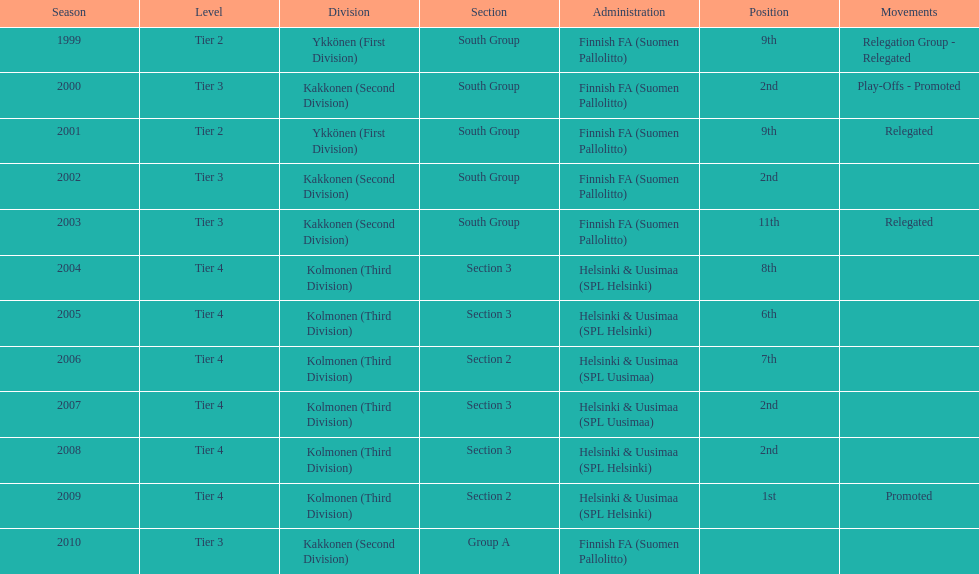Parse the full table. {'header': ['Season', 'Level', 'Division', 'Section', 'Administration', 'Position', 'Movements'], 'rows': [['1999', 'Tier 2', 'Ykkönen (First Division)', 'South Group', 'Finnish FA (Suomen Pallolitto)', '9th', 'Relegation Group - Relegated'], ['2000', 'Tier 3', 'Kakkonen (Second Division)', 'South Group', 'Finnish FA (Suomen Pallolitto)', '2nd', 'Play-Offs - Promoted'], ['2001', 'Tier 2', 'Ykkönen (First Division)', 'South Group', 'Finnish FA (Suomen Pallolitto)', '9th', 'Relegated'], ['2002', 'Tier 3', 'Kakkonen (Second Division)', 'South Group', 'Finnish FA (Suomen Pallolitto)', '2nd', ''], ['2003', 'Tier 3', 'Kakkonen (Second Division)', 'South Group', 'Finnish FA (Suomen Pallolitto)', '11th', 'Relegated'], ['2004', 'Tier 4', 'Kolmonen (Third Division)', 'Section 3', 'Helsinki & Uusimaa (SPL Helsinki)', '8th', ''], ['2005', 'Tier 4', 'Kolmonen (Third Division)', 'Section 3', 'Helsinki & Uusimaa (SPL Helsinki)', '6th', ''], ['2006', 'Tier 4', 'Kolmonen (Third Division)', 'Section 2', 'Helsinki & Uusimaa (SPL Uusimaa)', '7th', ''], ['2007', 'Tier 4', 'Kolmonen (Third Division)', 'Section 3', 'Helsinki & Uusimaa (SPL Uusimaa)', '2nd', ''], ['2008', 'Tier 4', 'Kolmonen (Third Division)', 'Section 3', 'Helsinki & Uusimaa (SPL Helsinki)', '2nd', ''], ['2009', 'Tier 4', 'Kolmonen (Third Division)', 'Section 2', 'Helsinki & Uusimaa (SPL Helsinki)', '1st', 'Promoted'], ['2010', 'Tier 3', 'Kakkonen (Second Division)', 'Group A', 'Finnish FA (Suomen Pallolitto)', '', '']]} When did they last rank 2nd in a year? 2008. 